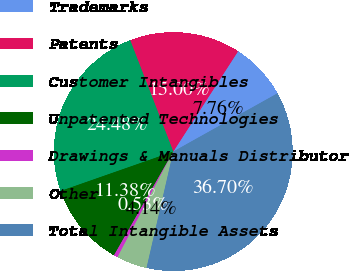<chart> <loc_0><loc_0><loc_500><loc_500><pie_chart><fcel>Trademarks<fcel>Patents<fcel>Customer Intangibles<fcel>Unpatented Technologies<fcel>Drawings & Manuals Distributor<fcel>Other<fcel>Total Intangible Assets<nl><fcel>7.76%<fcel>15.0%<fcel>24.48%<fcel>11.38%<fcel>0.53%<fcel>4.14%<fcel>36.7%<nl></chart> 